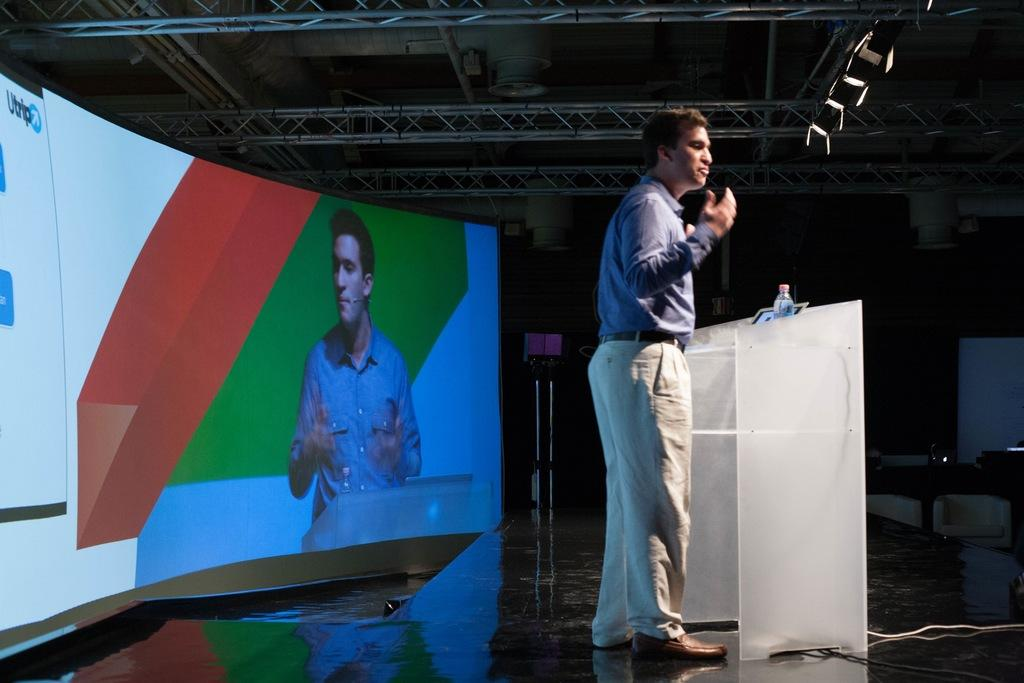What is the main activity taking place in the image? There is a guy giving a speech in the image. Can you describe the setting of the image? The setting is a conference. What can be seen in the background of the image? There is an electronic board in the background of the image. What information is displayed on the electronic board? The electronic board displays "U trip." How many steps are required to reach the comfort zone in the image? There is no mention of a comfort zone or steps in the image. 